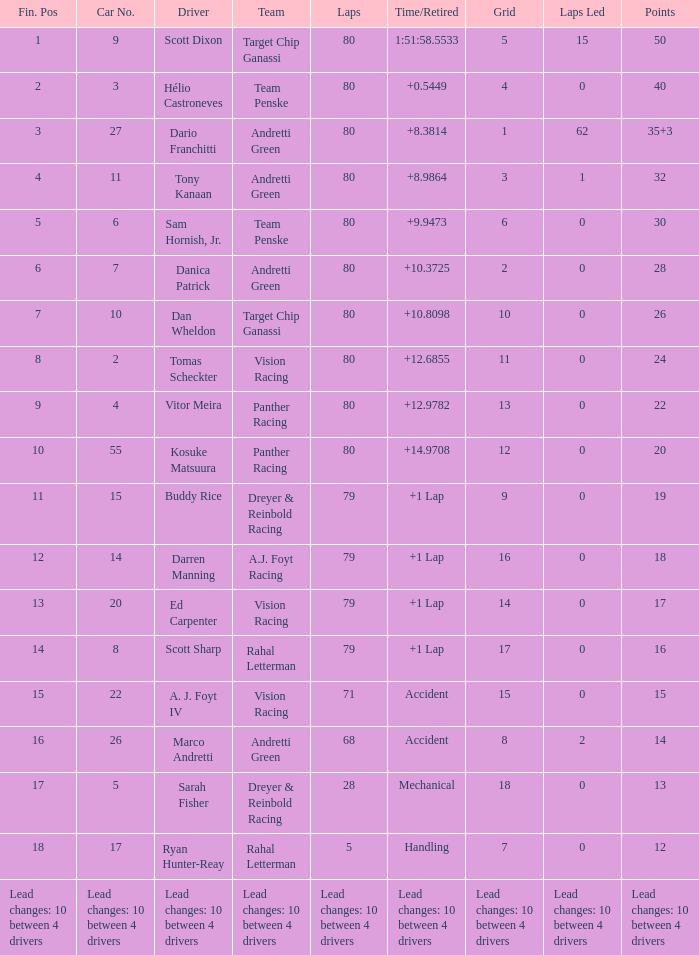What lattice contains 24 points? 11.0. 